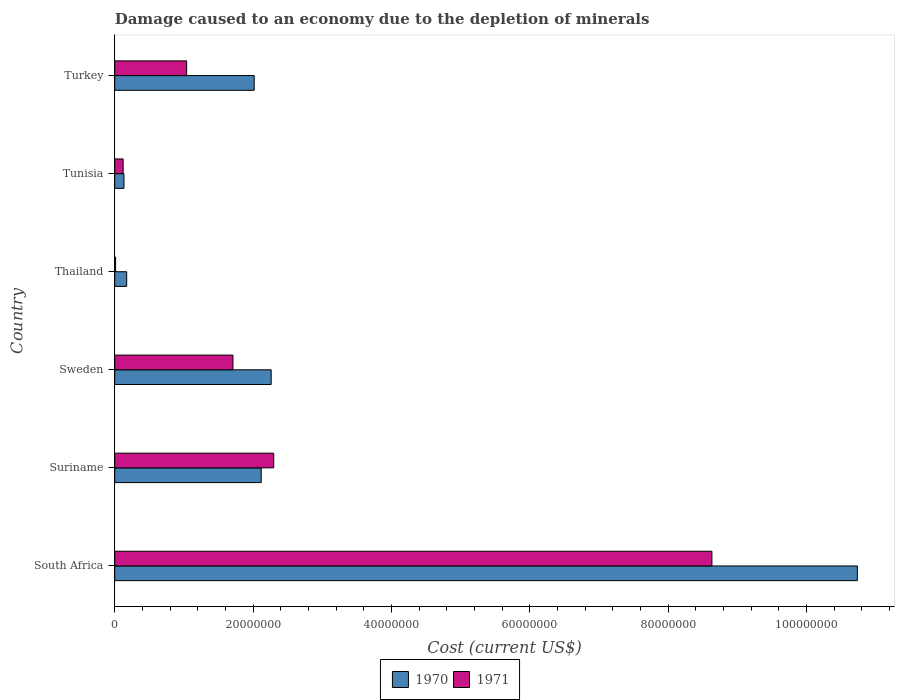How many bars are there on the 1st tick from the top?
Your answer should be compact. 2. How many bars are there on the 1st tick from the bottom?
Make the answer very short. 2. What is the label of the 5th group of bars from the top?
Your answer should be very brief. Suriname. In how many cases, is the number of bars for a given country not equal to the number of legend labels?
Offer a very short reply. 0. What is the cost of damage caused due to the depletion of minerals in 1970 in Tunisia?
Provide a short and direct response. 1.33e+06. Across all countries, what is the maximum cost of damage caused due to the depletion of minerals in 1971?
Keep it short and to the point. 8.63e+07. Across all countries, what is the minimum cost of damage caused due to the depletion of minerals in 1970?
Keep it short and to the point. 1.33e+06. In which country was the cost of damage caused due to the depletion of minerals in 1970 maximum?
Your response must be concise. South Africa. In which country was the cost of damage caused due to the depletion of minerals in 1970 minimum?
Offer a very short reply. Tunisia. What is the total cost of damage caused due to the depletion of minerals in 1970 in the graph?
Offer a very short reply. 1.74e+08. What is the difference between the cost of damage caused due to the depletion of minerals in 1970 in Sweden and that in Tunisia?
Provide a succinct answer. 2.13e+07. What is the difference between the cost of damage caused due to the depletion of minerals in 1970 in Turkey and the cost of damage caused due to the depletion of minerals in 1971 in Thailand?
Provide a short and direct response. 2.00e+07. What is the average cost of damage caused due to the depletion of minerals in 1970 per country?
Provide a succinct answer. 2.91e+07. What is the difference between the cost of damage caused due to the depletion of minerals in 1971 and cost of damage caused due to the depletion of minerals in 1970 in South Africa?
Keep it short and to the point. -2.10e+07. What is the ratio of the cost of damage caused due to the depletion of minerals in 1970 in Suriname to that in Sweden?
Provide a short and direct response. 0.94. Is the cost of damage caused due to the depletion of minerals in 1971 in Thailand less than that in Tunisia?
Ensure brevity in your answer.  Yes. Is the difference between the cost of damage caused due to the depletion of minerals in 1971 in Thailand and Tunisia greater than the difference between the cost of damage caused due to the depletion of minerals in 1970 in Thailand and Tunisia?
Ensure brevity in your answer.  No. What is the difference between the highest and the second highest cost of damage caused due to the depletion of minerals in 1970?
Keep it short and to the point. 8.47e+07. What is the difference between the highest and the lowest cost of damage caused due to the depletion of minerals in 1970?
Keep it short and to the point. 1.06e+08. Is the sum of the cost of damage caused due to the depletion of minerals in 1971 in Sweden and Thailand greater than the maximum cost of damage caused due to the depletion of minerals in 1970 across all countries?
Your response must be concise. No. What does the 2nd bar from the bottom in Thailand represents?
Provide a short and direct response. 1971. Are all the bars in the graph horizontal?
Your answer should be compact. Yes. How many countries are there in the graph?
Provide a succinct answer. 6. What is the difference between two consecutive major ticks on the X-axis?
Give a very brief answer. 2.00e+07. Are the values on the major ticks of X-axis written in scientific E-notation?
Keep it short and to the point. No. Does the graph contain any zero values?
Provide a short and direct response. No. How are the legend labels stacked?
Provide a succinct answer. Horizontal. What is the title of the graph?
Keep it short and to the point. Damage caused to an economy due to the depletion of minerals. Does "1968" appear as one of the legend labels in the graph?
Provide a succinct answer. No. What is the label or title of the X-axis?
Keep it short and to the point. Cost (current US$). What is the label or title of the Y-axis?
Ensure brevity in your answer.  Country. What is the Cost (current US$) in 1970 in South Africa?
Your answer should be very brief. 1.07e+08. What is the Cost (current US$) in 1971 in South Africa?
Provide a short and direct response. 8.63e+07. What is the Cost (current US$) in 1970 in Suriname?
Your answer should be compact. 2.12e+07. What is the Cost (current US$) of 1971 in Suriname?
Your response must be concise. 2.30e+07. What is the Cost (current US$) in 1970 in Sweden?
Offer a terse response. 2.26e+07. What is the Cost (current US$) of 1971 in Sweden?
Your answer should be compact. 1.71e+07. What is the Cost (current US$) in 1970 in Thailand?
Ensure brevity in your answer.  1.72e+06. What is the Cost (current US$) of 1971 in Thailand?
Make the answer very short. 1.21e+05. What is the Cost (current US$) in 1970 in Tunisia?
Make the answer very short. 1.33e+06. What is the Cost (current US$) of 1971 in Tunisia?
Ensure brevity in your answer.  1.21e+06. What is the Cost (current US$) in 1970 in Turkey?
Provide a short and direct response. 2.02e+07. What is the Cost (current US$) in 1971 in Turkey?
Keep it short and to the point. 1.04e+07. Across all countries, what is the maximum Cost (current US$) of 1970?
Offer a terse response. 1.07e+08. Across all countries, what is the maximum Cost (current US$) in 1971?
Keep it short and to the point. 8.63e+07. Across all countries, what is the minimum Cost (current US$) of 1970?
Your answer should be compact. 1.33e+06. Across all countries, what is the minimum Cost (current US$) in 1971?
Make the answer very short. 1.21e+05. What is the total Cost (current US$) in 1970 in the graph?
Offer a terse response. 1.74e+08. What is the total Cost (current US$) in 1971 in the graph?
Offer a very short reply. 1.38e+08. What is the difference between the Cost (current US$) in 1970 in South Africa and that in Suriname?
Provide a succinct answer. 8.62e+07. What is the difference between the Cost (current US$) in 1971 in South Africa and that in Suriname?
Make the answer very short. 6.33e+07. What is the difference between the Cost (current US$) of 1970 in South Africa and that in Sweden?
Give a very brief answer. 8.47e+07. What is the difference between the Cost (current US$) in 1971 in South Africa and that in Sweden?
Your response must be concise. 6.92e+07. What is the difference between the Cost (current US$) of 1970 in South Africa and that in Thailand?
Provide a short and direct response. 1.06e+08. What is the difference between the Cost (current US$) in 1971 in South Africa and that in Thailand?
Give a very brief answer. 8.62e+07. What is the difference between the Cost (current US$) of 1970 in South Africa and that in Tunisia?
Ensure brevity in your answer.  1.06e+08. What is the difference between the Cost (current US$) in 1971 in South Africa and that in Tunisia?
Keep it short and to the point. 8.51e+07. What is the difference between the Cost (current US$) in 1970 in South Africa and that in Turkey?
Your answer should be very brief. 8.72e+07. What is the difference between the Cost (current US$) in 1971 in South Africa and that in Turkey?
Give a very brief answer. 7.59e+07. What is the difference between the Cost (current US$) in 1970 in Suriname and that in Sweden?
Provide a succinct answer. -1.44e+06. What is the difference between the Cost (current US$) of 1971 in Suriname and that in Sweden?
Ensure brevity in your answer.  5.90e+06. What is the difference between the Cost (current US$) in 1970 in Suriname and that in Thailand?
Give a very brief answer. 1.94e+07. What is the difference between the Cost (current US$) of 1971 in Suriname and that in Thailand?
Give a very brief answer. 2.29e+07. What is the difference between the Cost (current US$) of 1970 in Suriname and that in Tunisia?
Your answer should be compact. 1.98e+07. What is the difference between the Cost (current US$) in 1971 in Suriname and that in Tunisia?
Provide a short and direct response. 2.18e+07. What is the difference between the Cost (current US$) of 1970 in Suriname and that in Turkey?
Make the answer very short. 1.02e+06. What is the difference between the Cost (current US$) of 1971 in Suriname and that in Turkey?
Give a very brief answer. 1.26e+07. What is the difference between the Cost (current US$) in 1970 in Sweden and that in Thailand?
Your response must be concise. 2.09e+07. What is the difference between the Cost (current US$) of 1971 in Sweden and that in Thailand?
Your answer should be compact. 1.70e+07. What is the difference between the Cost (current US$) of 1970 in Sweden and that in Tunisia?
Provide a short and direct response. 2.13e+07. What is the difference between the Cost (current US$) in 1971 in Sweden and that in Tunisia?
Ensure brevity in your answer.  1.59e+07. What is the difference between the Cost (current US$) of 1970 in Sweden and that in Turkey?
Keep it short and to the point. 2.46e+06. What is the difference between the Cost (current US$) in 1971 in Sweden and that in Turkey?
Offer a very short reply. 6.69e+06. What is the difference between the Cost (current US$) of 1970 in Thailand and that in Tunisia?
Your answer should be compact. 3.98e+05. What is the difference between the Cost (current US$) of 1971 in Thailand and that in Tunisia?
Provide a succinct answer. -1.09e+06. What is the difference between the Cost (current US$) of 1970 in Thailand and that in Turkey?
Provide a succinct answer. -1.84e+07. What is the difference between the Cost (current US$) in 1971 in Thailand and that in Turkey?
Offer a very short reply. -1.03e+07. What is the difference between the Cost (current US$) in 1970 in Tunisia and that in Turkey?
Offer a terse response. -1.88e+07. What is the difference between the Cost (current US$) in 1971 in Tunisia and that in Turkey?
Make the answer very short. -9.18e+06. What is the difference between the Cost (current US$) in 1970 in South Africa and the Cost (current US$) in 1971 in Suriname?
Your answer should be compact. 8.44e+07. What is the difference between the Cost (current US$) of 1970 in South Africa and the Cost (current US$) of 1971 in Sweden?
Offer a terse response. 9.03e+07. What is the difference between the Cost (current US$) of 1970 in South Africa and the Cost (current US$) of 1971 in Thailand?
Offer a terse response. 1.07e+08. What is the difference between the Cost (current US$) of 1970 in South Africa and the Cost (current US$) of 1971 in Tunisia?
Provide a short and direct response. 1.06e+08. What is the difference between the Cost (current US$) of 1970 in South Africa and the Cost (current US$) of 1971 in Turkey?
Your answer should be very brief. 9.70e+07. What is the difference between the Cost (current US$) in 1970 in Suriname and the Cost (current US$) in 1971 in Sweden?
Your response must be concise. 4.09e+06. What is the difference between the Cost (current US$) of 1970 in Suriname and the Cost (current US$) of 1971 in Thailand?
Provide a succinct answer. 2.11e+07. What is the difference between the Cost (current US$) in 1970 in Suriname and the Cost (current US$) in 1971 in Tunisia?
Offer a terse response. 2.00e+07. What is the difference between the Cost (current US$) of 1970 in Suriname and the Cost (current US$) of 1971 in Turkey?
Ensure brevity in your answer.  1.08e+07. What is the difference between the Cost (current US$) in 1970 in Sweden and the Cost (current US$) in 1971 in Thailand?
Make the answer very short. 2.25e+07. What is the difference between the Cost (current US$) of 1970 in Sweden and the Cost (current US$) of 1971 in Tunisia?
Offer a terse response. 2.14e+07. What is the difference between the Cost (current US$) in 1970 in Sweden and the Cost (current US$) in 1971 in Turkey?
Provide a short and direct response. 1.22e+07. What is the difference between the Cost (current US$) in 1970 in Thailand and the Cost (current US$) in 1971 in Tunisia?
Ensure brevity in your answer.  5.13e+05. What is the difference between the Cost (current US$) in 1970 in Thailand and the Cost (current US$) in 1971 in Turkey?
Keep it short and to the point. -8.67e+06. What is the difference between the Cost (current US$) of 1970 in Tunisia and the Cost (current US$) of 1971 in Turkey?
Your response must be concise. -9.07e+06. What is the average Cost (current US$) of 1970 per country?
Provide a succinct answer. 2.91e+07. What is the average Cost (current US$) of 1971 per country?
Your answer should be very brief. 2.30e+07. What is the difference between the Cost (current US$) in 1970 and Cost (current US$) in 1971 in South Africa?
Keep it short and to the point. 2.10e+07. What is the difference between the Cost (current US$) of 1970 and Cost (current US$) of 1971 in Suriname?
Provide a succinct answer. -1.81e+06. What is the difference between the Cost (current US$) in 1970 and Cost (current US$) in 1971 in Sweden?
Your answer should be very brief. 5.53e+06. What is the difference between the Cost (current US$) of 1970 and Cost (current US$) of 1971 in Thailand?
Your answer should be compact. 1.60e+06. What is the difference between the Cost (current US$) in 1970 and Cost (current US$) in 1971 in Tunisia?
Your answer should be very brief. 1.16e+05. What is the difference between the Cost (current US$) of 1970 and Cost (current US$) of 1971 in Turkey?
Ensure brevity in your answer.  9.76e+06. What is the ratio of the Cost (current US$) of 1970 in South Africa to that in Suriname?
Offer a terse response. 5.07. What is the ratio of the Cost (current US$) of 1971 in South Africa to that in Suriname?
Your answer should be compact. 3.76. What is the ratio of the Cost (current US$) of 1970 in South Africa to that in Sweden?
Provide a succinct answer. 4.75. What is the ratio of the Cost (current US$) of 1971 in South Africa to that in Sweden?
Your answer should be very brief. 5.05. What is the ratio of the Cost (current US$) in 1970 in South Africa to that in Thailand?
Your answer should be compact. 62.25. What is the ratio of the Cost (current US$) of 1971 in South Africa to that in Thailand?
Ensure brevity in your answer.  716.15. What is the ratio of the Cost (current US$) in 1970 in South Africa to that in Tunisia?
Ensure brevity in your answer.  80.9. What is the ratio of the Cost (current US$) in 1971 in South Africa to that in Tunisia?
Your response must be concise. 71.26. What is the ratio of the Cost (current US$) in 1970 in South Africa to that in Turkey?
Offer a very short reply. 5.33. What is the ratio of the Cost (current US$) of 1971 in South Africa to that in Turkey?
Make the answer very short. 8.3. What is the ratio of the Cost (current US$) of 1970 in Suriname to that in Sweden?
Provide a succinct answer. 0.94. What is the ratio of the Cost (current US$) in 1971 in Suriname to that in Sweden?
Offer a terse response. 1.35. What is the ratio of the Cost (current US$) in 1970 in Suriname to that in Thailand?
Offer a terse response. 12.28. What is the ratio of the Cost (current US$) of 1971 in Suriname to that in Thailand?
Keep it short and to the point. 190.64. What is the ratio of the Cost (current US$) of 1970 in Suriname to that in Tunisia?
Provide a short and direct response. 15.96. What is the ratio of the Cost (current US$) of 1971 in Suriname to that in Tunisia?
Offer a terse response. 18.97. What is the ratio of the Cost (current US$) of 1970 in Suriname to that in Turkey?
Give a very brief answer. 1.05. What is the ratio of the Cost (current US$) of 1971 in Suriname to that in Turkey?
Your answer should be very brief. 2.21. What is the ratio of the Cost (current US$) of 1970 in Sweden to that in Thailand?
Provide a short and direct response. 13.11. What is the ratio of the Cost (current US$) in 1971 in Sweden to that in Thailand?
Give a very brief answer. 141.73. What is the ratio of the Cost (current US$) of 1970 in Sweden to that in Tunisia?
Give a very brief answer. 17.04. What is the ratio of the Cost (current US$) in 1971 in Sweden to that in Tunisia?
Your answer should be very brief. 14.1. What is the ratio of the Cost (current US$) of 1970 in Sweden to that in Turkey?
Offer a terse response. 1.12. What is the ratio of the Cost (current US$) in 1971 in Sweden to that in Turkey?
Keep it short and to the point. 1.64. What is the ratio of the Cost (current US$) in 1970 in Thailand to that in Tunisia?
Offer a terse response. 1.3. What is the ratio of the Cost (current US$) of 1971 in Thailand to that in Tunisia?
Ensure brevity in your answer.  0.1. What is the ratio of the Cost (current US$) of 1970 in Thailand to that in Turkey?
Your answer should be very brief. 0.09. What is the ratio of the Cost (current US$) in 1971 in Thailand to that in Turkey?
Provide a short and direct response. 0.01. What is the ratio of the Cost (current US$) of 1970 in Tunisia to that in Turkey?
Offer a terse response. 0.07. What is the ratio of the Cost (current US$) in 1971 in Tunisia to that in Turkey?
Offer a terse response. 0.12. What is the difference between the highest and the second highest Cost (current US$) of 1970?
Make the answer very short. 8.47e+07. What is the difference between the highest and the second highest Cost (current US$) in 1971?
Keep it short and to the point. 6.33e+07. What is the difference between the highest and the lowest Cost (current US$) in 1970?
Keep it short and to the point. 1.06e+08. What is the difference between the highest and the lowest Cost (current US$) of 1971?
Keep it short and to the point. 8.62e+07. 